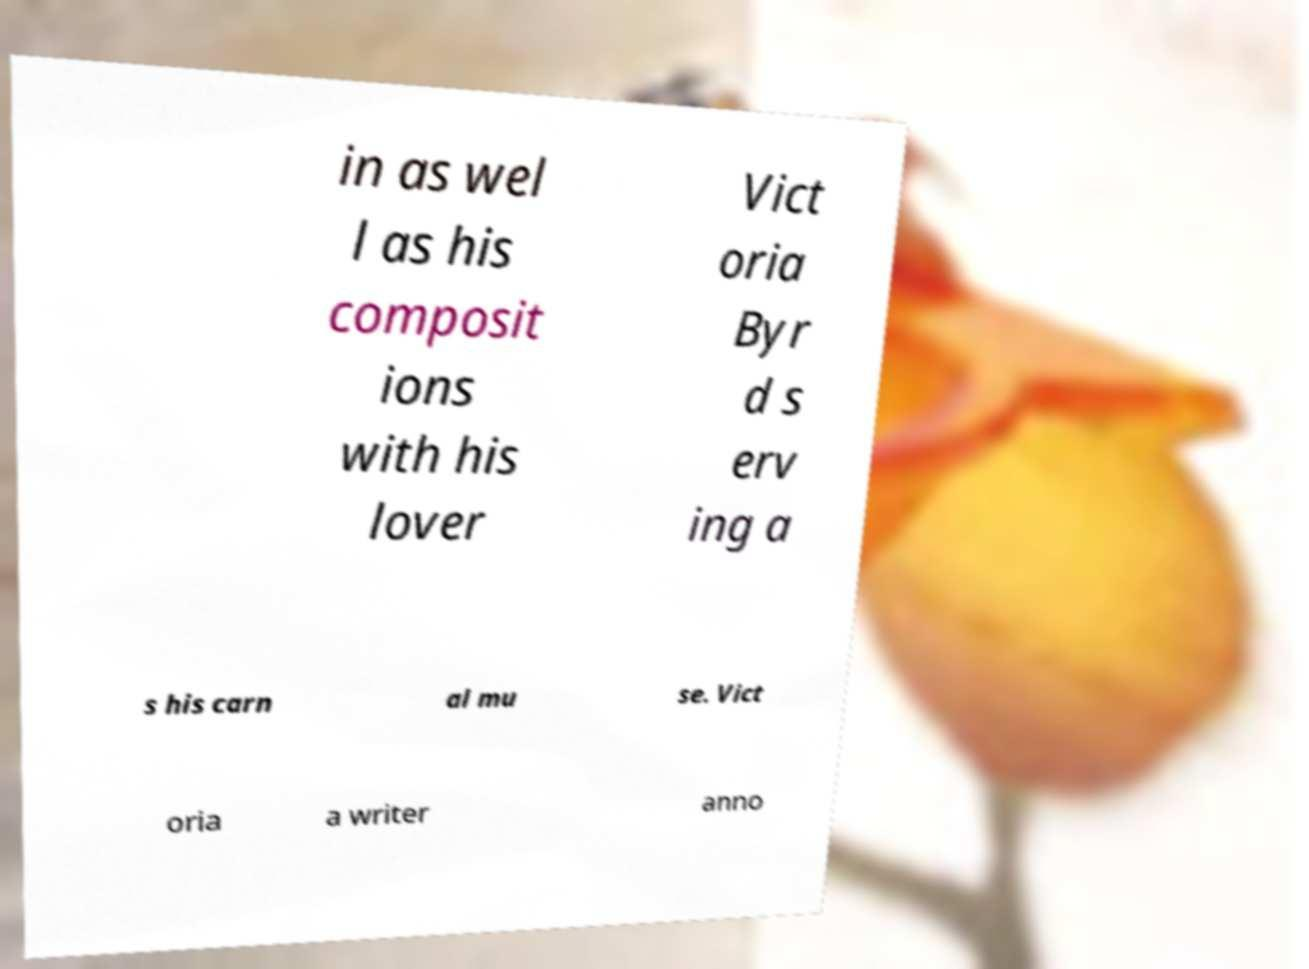Could you assist in decoding the text presented in this image and type it out clearly? in as wel l as his composit ions with his lover Vict oria Byr d s erv ing a s his carn al mu se. Vict oria a writer anno 